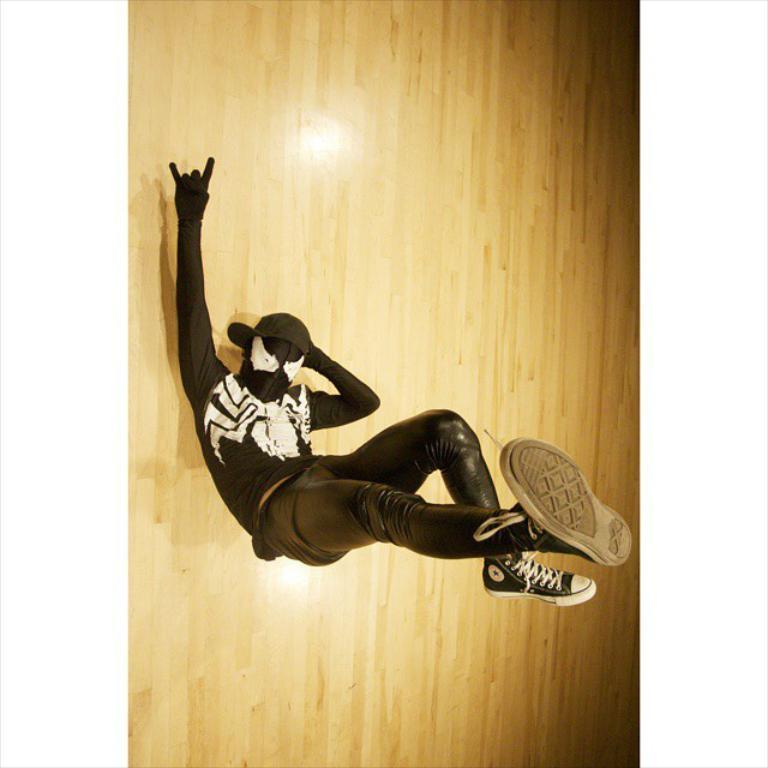Can you describe this image briefly? This picture shows a man laying on the back and lifted his legs on the floor and he wore a cap on his head and a mask to his face and he wore a black color dress. 